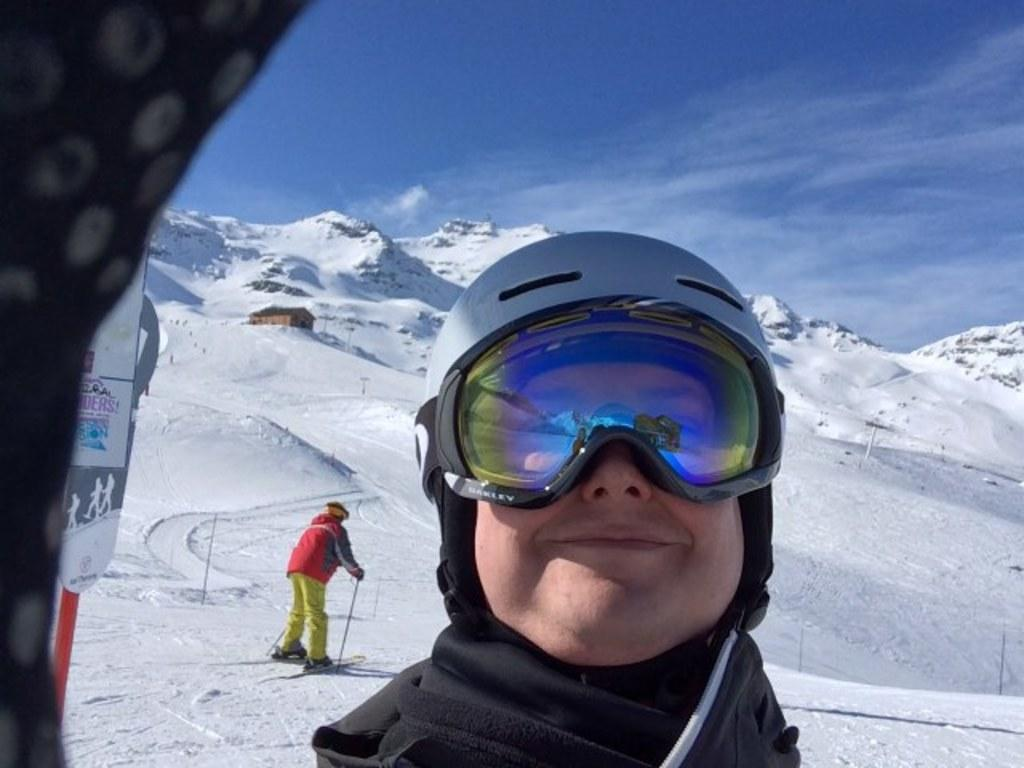What can be seen in the image? There is a person in the image. Can you describe the person's appearance? The person is wearing glasses. What is the person doing in the image? The person is standing. What can be seen in the background of the image? There are mountains with ice, a person standing on a skateboard, and clouds visible in the background. What type of whip is the person using to hit the pie in the image? There is no whip or pie present in the image. What road can be seen in the image? There is no road visible in the image. 